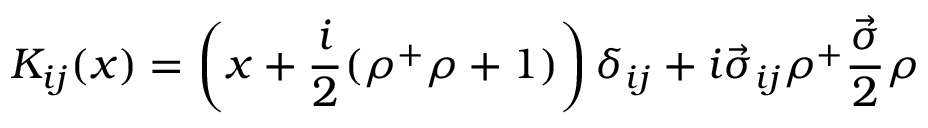<formula> <loc_0><loc_0><loc_500><loc_500>K _ { i j } ( x ) = \left ( x + \frac { i } { 2 } ( \rho ^ { + } \rho + 1 ) \right ) \delta _ { i j } + i \vec { \sigma } _ { i j } \rho ^ { + } \frac { \vec { \sigma } } { 2 } \rho</formula> 